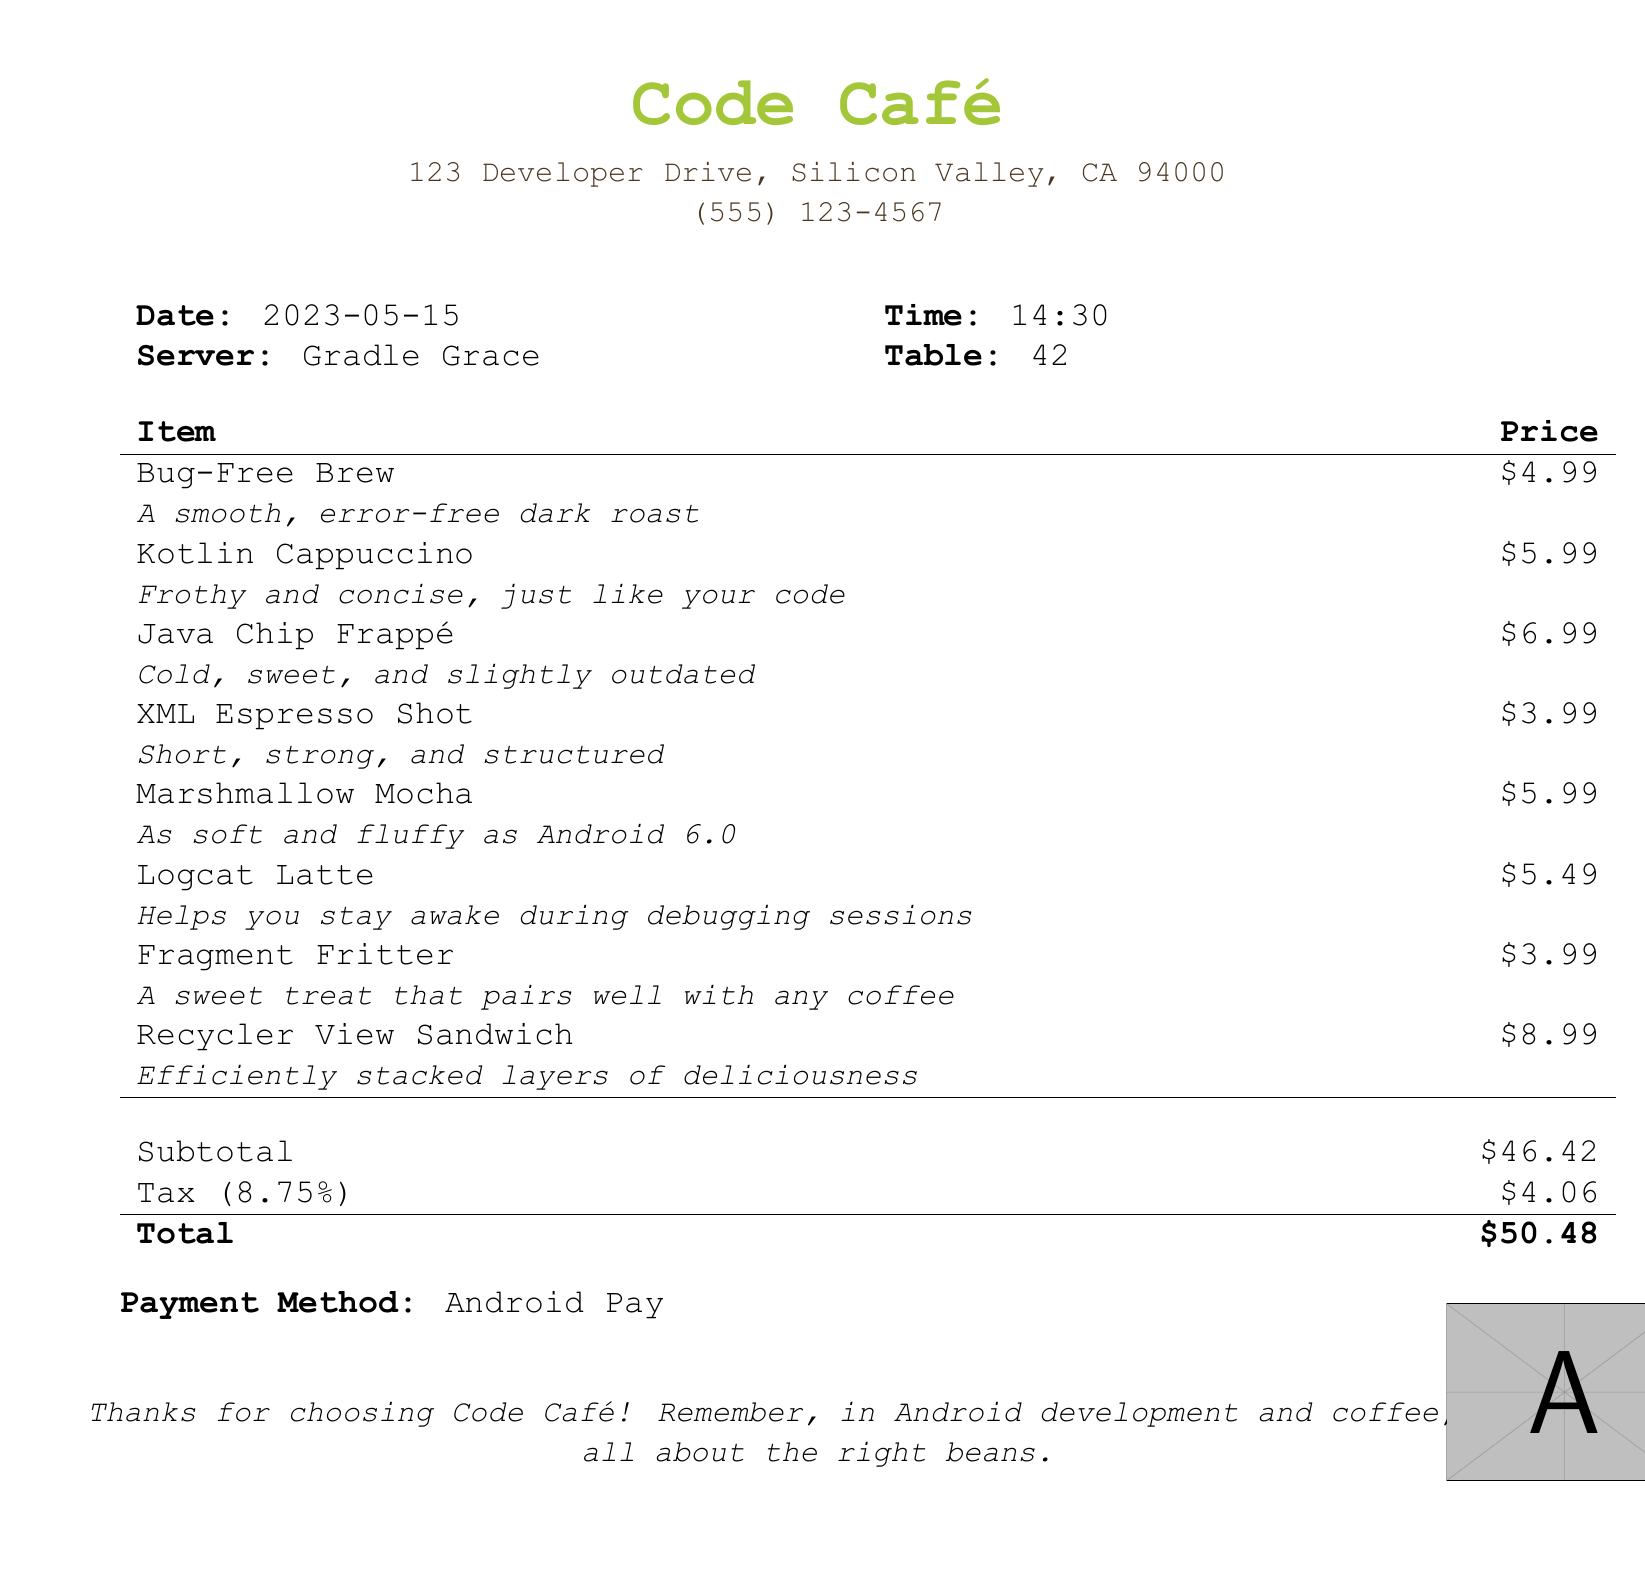What is the name of the café? The name of the café is prominently displayed at the top of the document.
Answer: Code Café Who was the server? The document includes the name of the server next to the date and time.
Answer: Gradle Grace What is the price of the Bug-Free Brew? The price for the Bug-Free Brew is listed next to the item in the table.
Answer: $4.99 How much is the total bill? The total is clearly marked at the bottom of the pricing section of the document.
Answer: $50.48 What payment method was used? The document indicates the payment method near the end.
Answer: Android Pay What was the date of the visit? The date is listed in the header section of the document.
Answer: 2023-05-15 What is the tax percentage applied? The tax percentage is indicated in the subtotal section of the bill.
Answer: 8.75% Which item is described as "efficiently stacked layers of deliciousness"? The description accompanies a specific menu item in the bill.
Answer: Recycler View Sandwich How many items are listed on the menu? The number of items can be counted from the itemized list in the document.
Answer: 8 